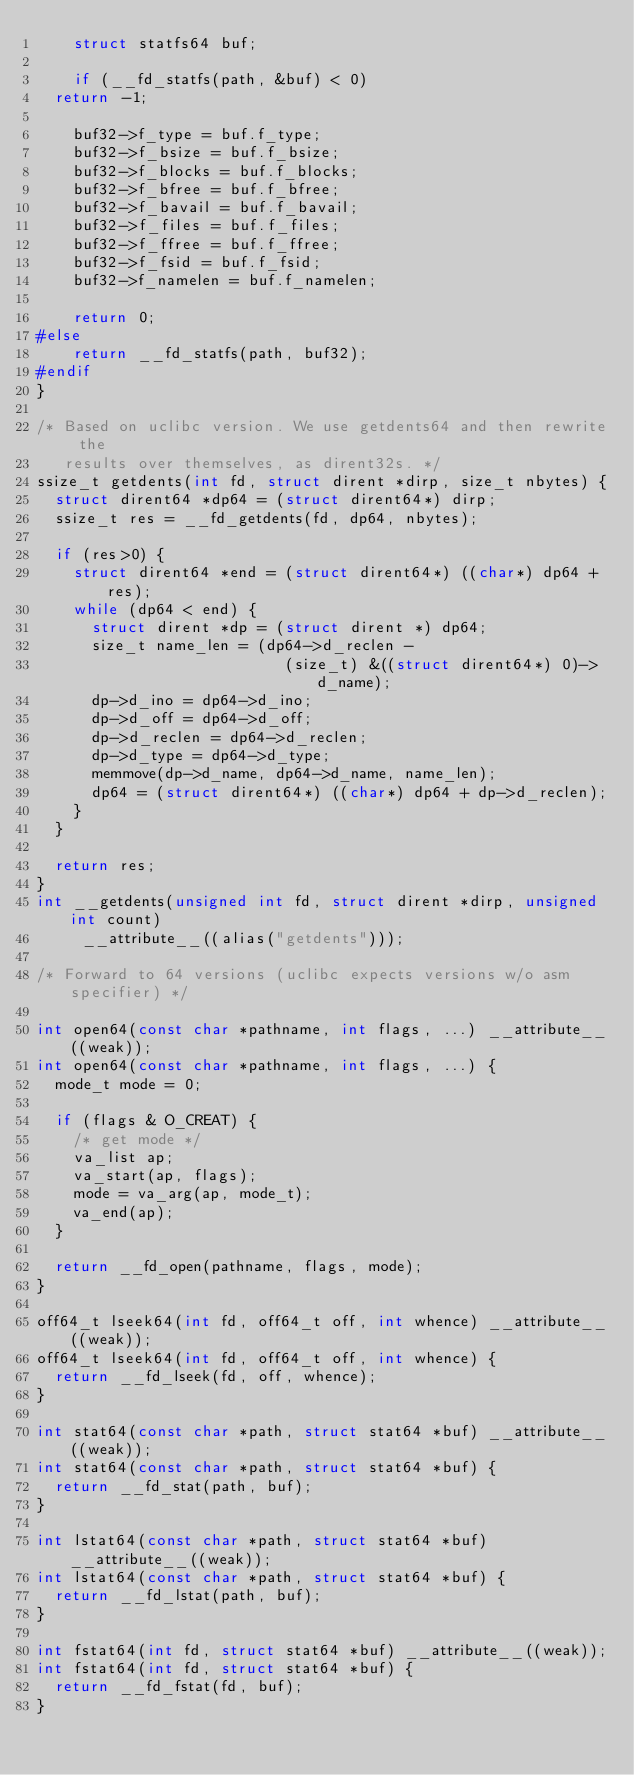<code> <loc_0><loc_0><loc_500><loc_500><_C_>    struct statfs64 buf;

    if (__fd_statfs(path, &buf) < 0)
	return -1;

    buf32->f_type = buf.f_type;
    buf32->f_bsize = buf.f_bsize;
    buf32->f_blocks = buf.f_blocks;
    buf32->f_bfree = buf.f_bfree;
    buf32->f_bavail = buf.f_bavail;
    buf32->f_files = buf.f_files;
    buf32->f_ffree = buf.f_ffree;
    buf32->f_fsid = buf.f_fsid;
    buf32->f_namelen = buf.f_namelen;

    return 0;
#else
    return __fd_statfs(path, buf32);
#endif
}

/* Based on uclibc version. We use getdents64 and then rewrite the
   results over themselves, as dirent32s. */
ssize_t getdents(int fd, struct dirent *dirp, size_t nbytes) {
  struct dirent64 *dp64 = (struct dirent64*) dirp;
  ssize_t res = __fd_getdents(fd, dp64, nbytes);

  if (res>0) {
    struct dirent64 *end = (struct dirent64*) ((char*) dp64 + res);
    while (dp64 < end) {
      struct dirent *dp = (struct dirent *) dp64;
      size_t name_len = (dp64->d_reclen - 
                           (size_t) &((struct dirent64*) 0)->d_name);
      dp->d_ino = dp64->d_ino;
      dp->d_off = dp64->d_off;
      dp->d_reclen = dp64->d_reclen;
      dp->d_type = dp64->d_type;
      memmove(dp->d_name, dp64->d_name, name_len);
      dp64 = (struct dirent64*) ((char*) dp64 + dp->d_reclen);
    }
  }

  return res;
}
int __getdents(unsigned int fd, struct dirent *dirp, unsigned int count)
     __attribute__((alias("getdents")));

/* Forward to 64 versions (uclibc expects versions w/o asm specifier) */

int open64(const char *pathname, int flags, ...) __attribute__((weak));
int open64(const char *pathname, int flags, ...) {
  mode_t mode = 0;

  if (flags & O_CREAT) {
    /* get mode */
    va_list ap;
    va_start(ap, flags);
    mode = va_arg(ap, mode_t);
    va_end(ap);
  }

  return __fd_open(pathname, flags, mode);
}

off64_t lseek64(int fd, off64_t off, int whence) __attribute__((weak));
off64_t lseek64(int fd, off64_t off, int whence) {
  return __fd_lseek(fd, off, whence);
}

int stat64(const char *path, struct stat64 *buf) __attribute__((weak));
int stat64(const char *path, struct stat64 *buf) {
  return __fd_stat(path, buf);
}

int lstat64(const char *path, struct stat64 *buf) __attribute__((weak));
int lstat64(const char *path, struct stat64 *buf) {
  return __fd_lstat(path, buf);
}

int fstat64(int fd, struct stat64 *buf) __attribute__((weak));
int fstat64(int fd, struct stat64 *buf) {
  return __fd_fstat(fd, buf);
}
</code> 